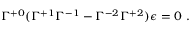<formula> <loc_0><loc_0><loc_500><loc_500>\Gamma ^ { + 0 } ( \Gamma ^ { + 1 } \Gamma ^ { - 1 } - \Gamma ^ { - 2 } \Gamma ^ { + 2 } ) \epsilon = 0 .</formula> 